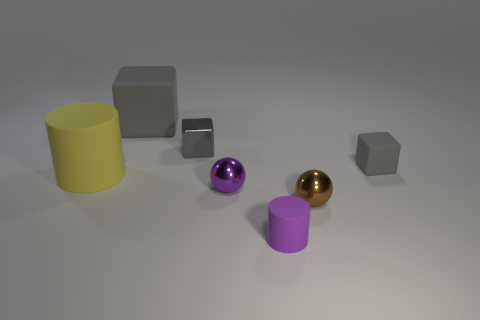Is the number of balls in front of the purple sphere greater than the number of big red matte balls? While your question assumes the presence of big red matte balls, upon closer inspection of the image, there are no red balls to compare with. As such, if we are to answer your question based on the objects present, the number of balls in front of the purple sphere, which is one gold ball, is not greater than the number of big red matte balls because there aren't any in the image. 